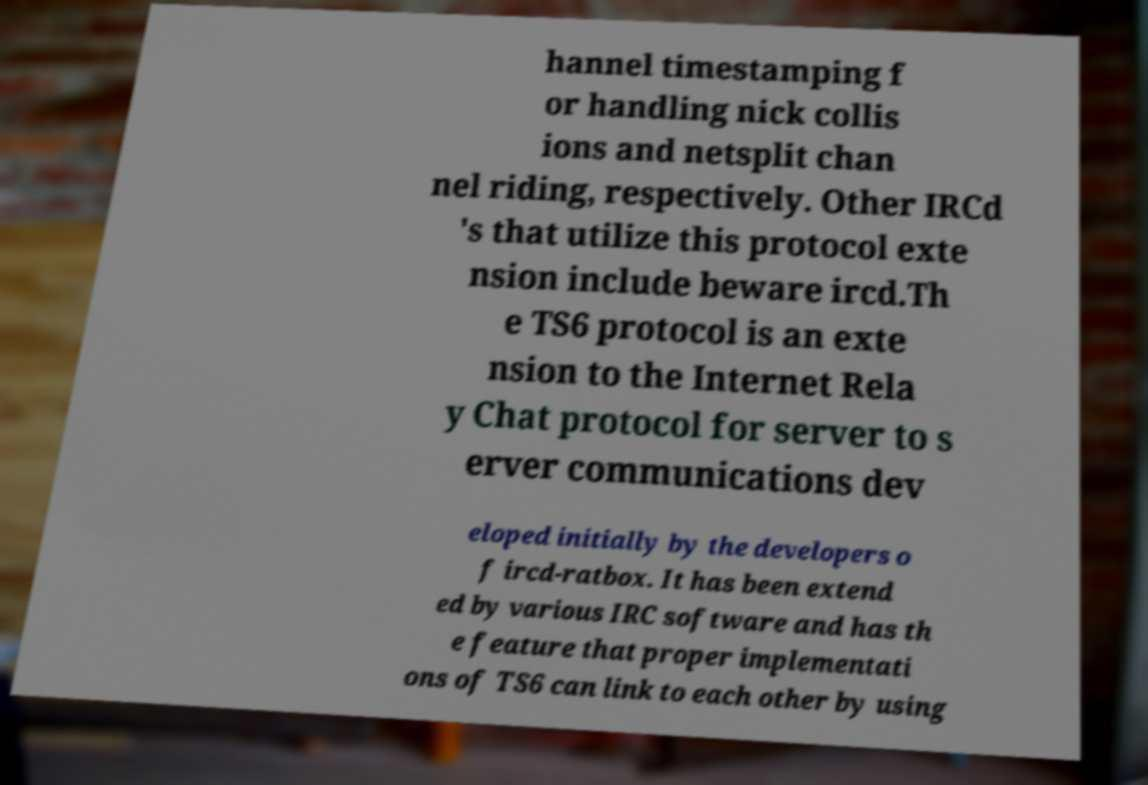What messages or text are displayed in this image? I need them in a readable, typed format. hannel timestamping f or handling nick collis ions and netsplit chan nel riding, respectively. Other IRCd 's that utilize this protocol exte nsion include beware ircd.Th e TS6 protocol is an exte nsion to the Internet Rela y Chat protocol for server to s erver communications dev eloped initially by the developers o f ircd-ratbox. It has been extend ed by various IRC software and has th e feature that proper implementati ons of TS6 can link to each other by using 